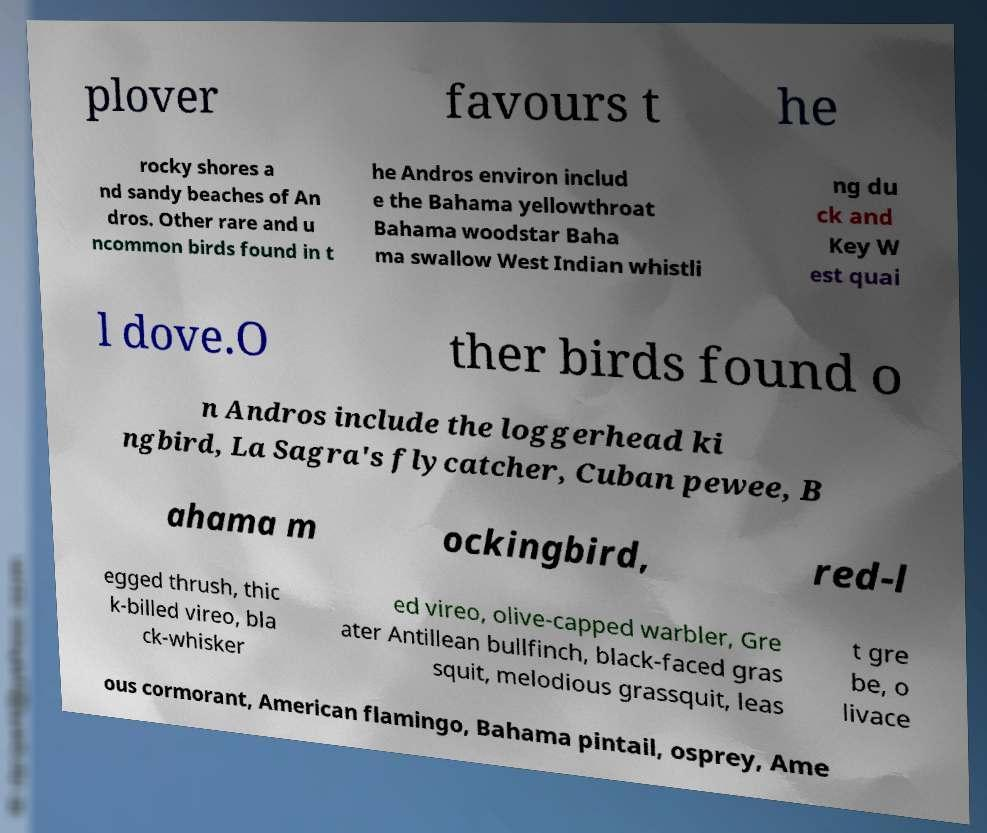Could you assist in decoding the text presented in this image and type it out clearly? plover favours t he rocky shores a nd sandy beaches of An dros. Other rare and u ncommon birds found in t he Andros environ includ e the Bahama yellowthroat Bahama woodstar Baha ma swallow West Indian whistli ng du ck and Key W est quai l dove.O ther birds found o n Andros include the loggerhead ki ngbird, La Sagra's flycatcher, Cuban pewee, B ahama m ockingbird, red-l egged thrush, thic k-billed vireo, bla ck-whisker ed vireo, olive-capped warbler, Gre ater Antillean bullfinch, black-faced gras squit, melodious grassquit, leas t gre be, o livace ous cormorant, American flamingo, Bahama pintail, osprey, Ame 